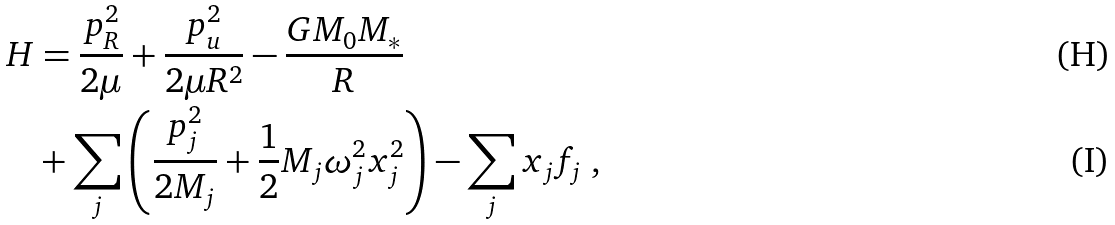<formula> <loc_0><loc_0><loc_500><loc_500>H & = \frac { p _ { R } ^ { 2 } } { 2 \mu } + \frac { p _ { u } ^ { 2 } } { 2 \mu R ^ { 2 } } - \frac { G M _ { 0 } M _ { * } } { R } \\ & + \sum _ { j } \left ( \frac { p _ { j } ^ { 2 } } { 2 M _ { j } } + \frac { 1 } { 2 } M _ { j } \omega _ { j } ^ { 2 } x _ { j } ^ { 2 } \right ) - \sum _ { j } x _ { j } f _ { j } \ ,</formula> 